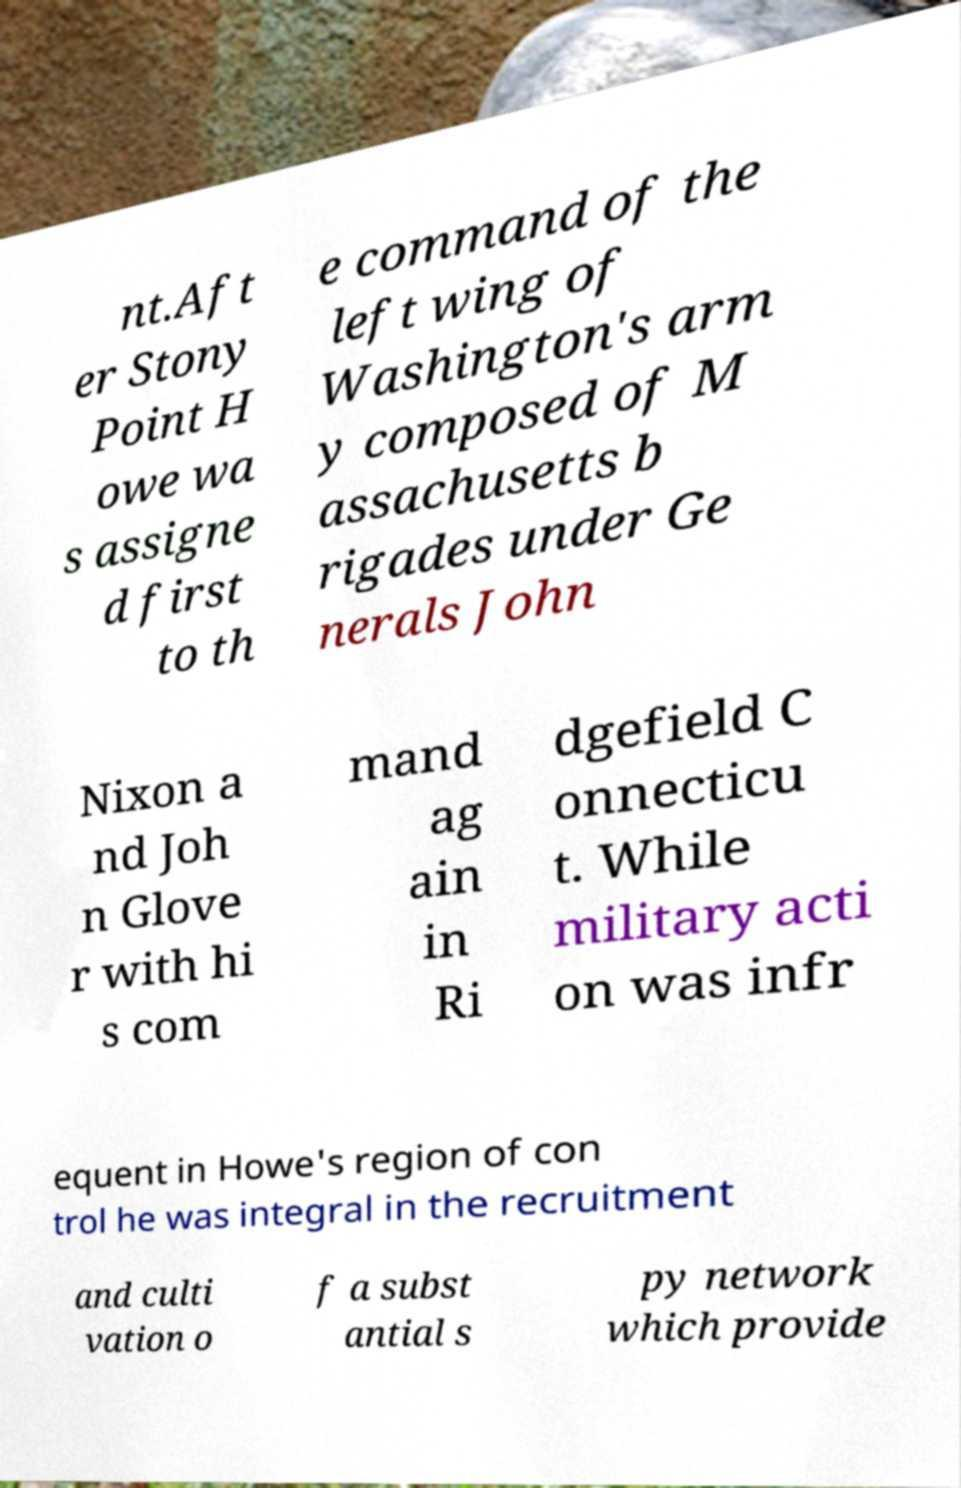Can you accurately transcribe the text from the provided image for me? nt.Aft er Stony Point H owe wa s assigne d first to th e command of the left wing of Washington's arm y composed of M assachusetts b rigades under Ge nerals John Nixon a nd Joh n Glove r with hi s com mand ag ain in Ri dgefield C onnecticu t. While military acti on was infr equent in Howe's region of con trol he was integral in the recruitment and culti vation o f a subst antial s py network which provide 